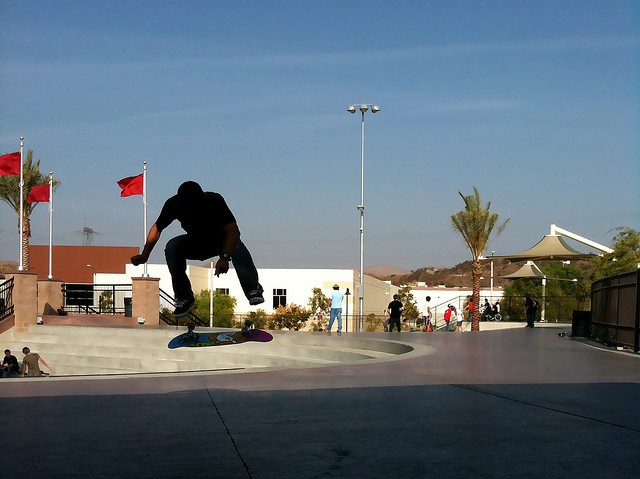Describe the objects in this image and their specific colors. I can see people in gray, black, darkgray, and white tones, skateboard in gray, black, navy, and darkgray tones, people in gray and lightblue tones, people in gray, maroon, and black tones, and people in gray, black, and beige tones in this image. 